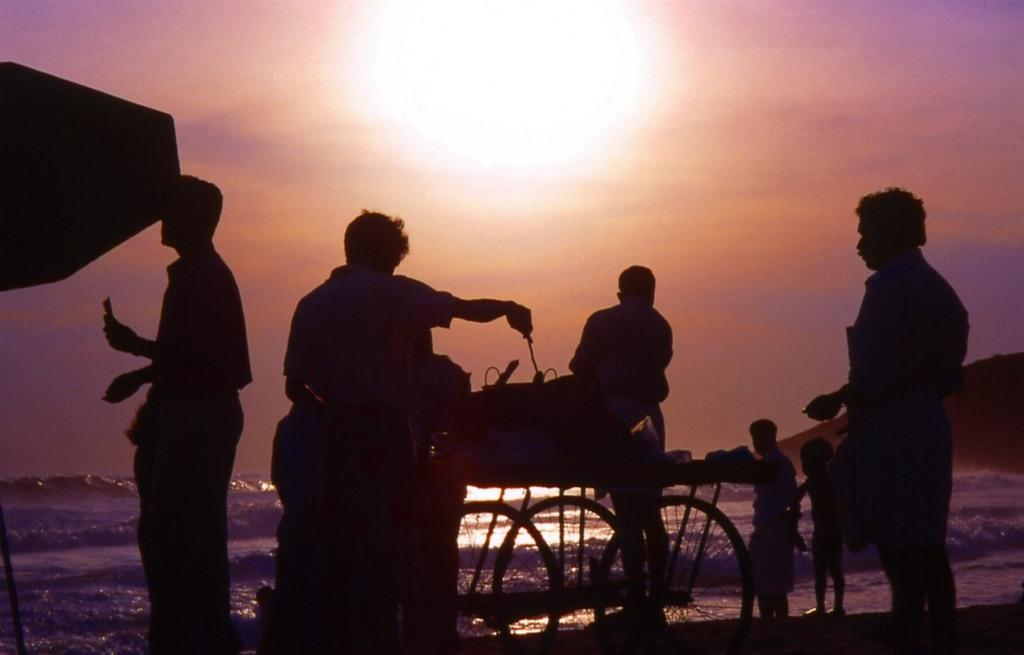What can be seen in the image involving people? There are people standing in the image. What object is present in the image that is typically used for transportation or carrying items? There is a cart in the image. What activity is the man on the cart engaged in? A man is cooking on the cart. What natural element is visible in the image? There is water visible in the image. What is the condition of the sky in the image? Sunlight is present in the sky. What type of bushes can be seen growing near the cart in the image? There are no bushes present in the image; it only features people, a cart, a man cooking, water, and sunlight. What is the opinion of the people standing in the image about the food being cooked? The image does not provide any information about the opinions of the people standing in the image. 